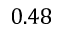<formula> <loc_0><loc_0><loc_500><loc_500>0 . 4 8</formula> 